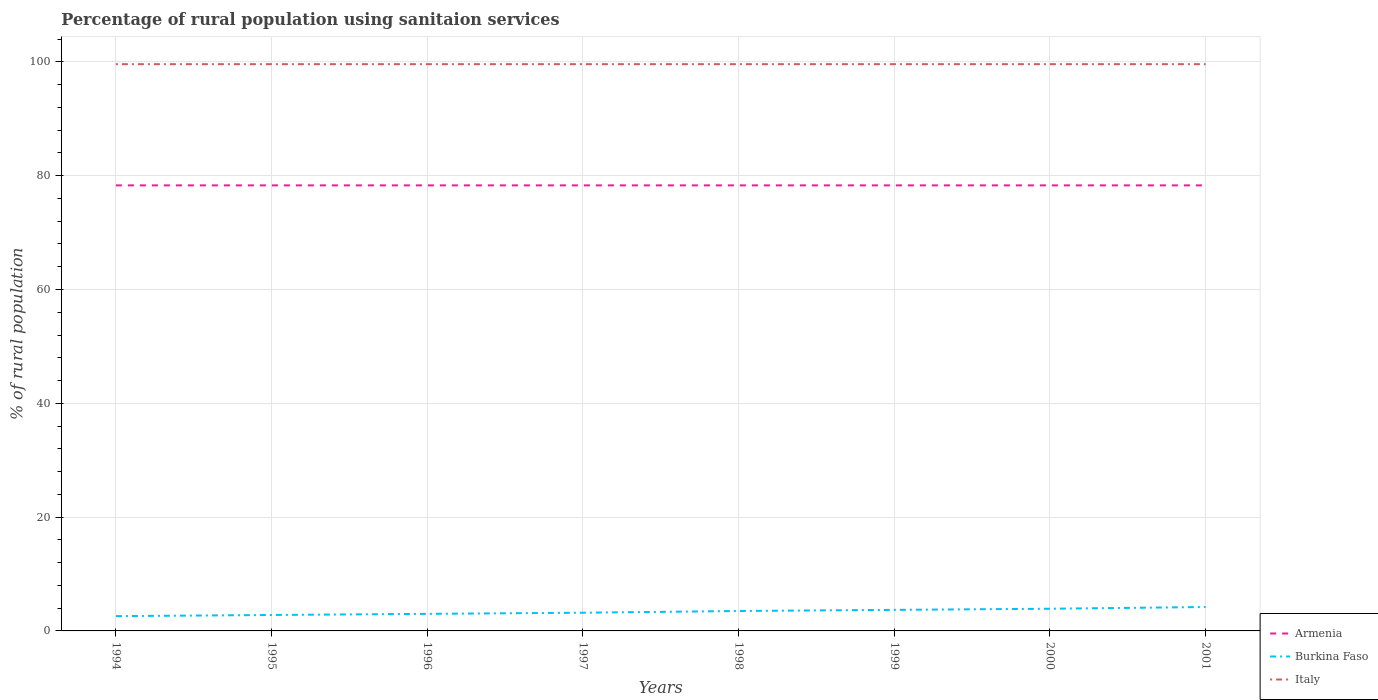Does the line corresponding to Italy intersect with the line corresponding to Armenia?
Offer a terse response. No. Is the number of lines equal to the number of legend labels?
Provide a short and direct response. Yes. Across all years, what is the maximum percentage of rural population using sanitaion services in Burkina Faso?
Your answer should be compact. 2.6. In which year was the percentage of rural population using sanitaion services in Armenia maximum?
Ensure brevity in your answer.  1994. What is the difference between the highest and the second highest percentage of rural population using sanitaion services in Armenia?
Keep it short and to the point. 0. How many lines are there?
Ensure brevity in your answer.  3. What is the difference between two consecutive major ticks on the Y-axis?
Make the answer very short. 20. Are the values on the major ticks of Y-axis written in scientific E-notation?
Offer a terse response. No. Does the graph contain grids?
Offer a very short reply. Yes. How are the legend labels stacked?
Your response must be concise. Vertical. What is the title of the graph?
Your answer should be very brief. Percentage of rural population using sanitaion services. What is the label or title of the Y-axis?
Provide a succinct answer. % of rural population. What is the % of rural population in Armenia in 1994?
Provide a succinct answer. 78.3. What is the % of rural population of Burkina Faso in 1994?
Keep it short and to the point. 2.6. What is the % of rural population of Italy in 1994?
Your answer should be very brief. 99.6. What is the % of rural population in Armenia in 1995?
Your answer should be compact. 78.3. What is the % of rural population of Italy in 1995?
Your answer should be very brief. 99.6. What is the % of rural population in Armenia in 1996?
Make the answer very short. 78.3. What is the % of rural population in Burkina Faso in 1996?
Provide a succinct answer. 3. What is the % of rural population in Italy in 1996?
Offer a terse response. 99.6. What is the % of rural population of Armenia in 1997?
Give a very brief answer. 78.3. What is the % of rural population in Italy in 1997?
Ensure brevity in your answer.  99.6. What is the % of rural population of Armenia in 1998?
Ensure brevity in your answer.  78.3. What is the % of rural population of Italy in 1998?
Provide a succinct answer. 99.6. What is the % of rural population of Armenia in 1999?
Your answer should be very brief. 78.3. What is the % of rural population in Burkina Faso in 1999?
Give a very brief answer. 3.7. What is the % of rural population of Italy in 1999?
Ensure brevity in your answer.  99.6. What is the % of rural population of Armenia in 2000?
Ensure brevity in your answer.  78.3. What is the % of rural population in Italy in 2000?
Provide a short and direct response. 99.6. What is the % of rural population in Armenia in 2001?
Make the answer very short. 78.3. What is the % of rural population in Italy in 2001?
Provide a short and direct response. 99.6. Across all years, what is the maximum % of rural population in Armenia?
Your answer should be compact. 78.3. Across all years, what is the maximum % of rural population in Italy?
Provide a succinct answer. 99.6. Across all years, what is the minimum % of rural population of Armenia?
Offer a terse response. 78.3. Across all years, what is the minimum % of rural population of Burkina Faso?
Your response must be concise. 2.6. Across all years, what is the minimum % of rural population in Italy?
Offer a very short reply. 99.6. What is the total % of rural population of Armenia in the graph?
Make the answer very short. 626.4. What is the total % of rural population in Burkina Faso in the graph?
Ensure brevity in your answer.  26.9. What is the total % of rural population of Italy in the graph?
Ensure brevity in your answer.  796.8. What is the difference between the % of rural population in Armenia in 1994 and that in 1996?
Provide a succinct answer. 0. What is the difference between the % of rural population of Italy in 1994 and that in 1996?
Keep it short and to the point. 0. What is the difference between the % of rural population of Armenia in 1994 and that in 1997?
Provide a succinct answer. 0. What is the difference between the % of rural population in Burkina Faso in 1994 and that in 1997?
Your answer should be compact. -0.6. What is the difference between the % of rural population in Burkina Faso in 1994 and that in 1998?
Provide a succinct answer. -0.9. What is the difference between the % of rural population in Italy in 1994 and that in 1998?
Offer a very short reply. 0. What is the difference between the % of rural population in Italy in 1994 and that in 1999?
Provide a succinct answer. 0. What is the difference between the % of rural population of Armenia in 1994 and that in 2000?
Give a very brief answer. 0. What is the difference between the % of rural population of Burkina Faso in 1994 and that in 2000?
Provide a short and direct response. -1.3. What is the difference between the % of rural population in Burkina Faso in 1994 and that in 2001?
Offer a very short reply. -1.6. What is the difference between the % of rural population of Burkina Faso in 1995 and that in 1996?
Offer a very short reply. -0.2. What is the difference between the % of rural population in Italy in 1995 and that in 1996?
Make the answer very short. 0. What is the difference between the % of rural population in Burkina Faso in 1995 and that in 1997?
Keep it short and to the point. -0.4. What is the difference between the % of rural population of Burkina Faso in 1995 and that in 1998?
Your response must be concise. -0.7. What is the difference between the % of rural population in Armenia in 1995 and that in 1999?
Your answer should be compact. 0. What is the difference between the % of rural population of Burkina Faso in 1995 and that in 1999?
Your answer should be compact. -0.9. What is the difference between the % of rural population of Armenia in 1995 and that in 2000?
Ensure brevity in your answer.  0. What is the difference between the % of rural population in Burkina Faso in 1995 and that in 2000?
Your response must be concise. -1.1. What is the difference between the % of rural population in Italy in 1995 and that in 2000?
Ensure brevity in your answer.  0. What is the difference between the % of rural population in Armenia in 1995 and that in 2001?
Your answer should be very brief. 0. What is the difference between the % of rural population in Armenia in 1996 and that in 1997?
Make the answer very short. 0. What is the difference between the % of rural population of Italy in 1996 and that in 1997?
Offer a terse response. 0. What is the difference between the % of rural population of Burkina Faso in 1996 and that in 1998?
Your response must be concise. -0.5. What is the difference between the % of rural population of Italy in 1996 and that in 1998?
Keep it short and to the point. 0. What is the difference between the % of rural population of Italy in 1996 and that in 1999?
Offer a very short reply. 0. What is the difference between the % of rural population of Burkina Faso in 1996 and that in 2000?
Offer a very short reply. -0.9. What is the difference between the % of rural population of Burkina Faso in 1996 and that in 2001?
Offer a terse response. -1.2. What is the difference between the % of rural population in Italy in 1997 and that in 1998?
Your answer should be very brief. 0. What is the difference between the % of rural population in Burkina Faso in 1997 and that in 2000?
Your response must be concise. -0.7. What is the difference between the % of rural population of Italy in 1997 and that in 2000?
Ensure brevity in your answer.  0. What is the difference between the % of rural population in Italy in 1998 and that in 1999?
Your answer should be very brief. 0. What is the difference between the % of rural population of Armenia in 1998 and that in 2000?
Your response must be concise. 0. What is the difference between the % of rural population of Armenia in 1998 and that in 2001?
Your answer should be compact. 0. What is the difference between the % of rural population of Burkina Faso in 1998 and that in 2001?
Offer a very short reply. -0.7. What is the difference between the % of rural population of Burkina Faso in 1999 and that in 2000?
Your answer should be very brief. -0.2. What is the difference between the % of rural population of Italy in 1999 and that in 2000?
Offer a very short reply. 0. What is the difference between the % of rural population of Armenia in 1999 and that in 2001?
Your answer should be very brief. 0. What is the difference between the % of rural population in Burkina Faso in 1999 and that in 2001?
Give a very brief answer. -0.5. What is the difference between the % of rural population in Burkina Faso in 2000 and that in 2001?
Offer a terse response. -0.3. What is the difference between the % of rural population in Italy in 2000 and that in 2001?
Your answer should be compact. 0. What is the difference between the % of rural population of Armenia in 1994 and the % of rural population of Burkina Faso in 1995?
Provide a succinct answer. 75.5. What is the difference between the % of rural population of Armenia in 1994 and the % of rural population of Italy in 1995?
Give a very brief answer. -21.3. What is the difference between the % of rural population of Burkina Faso in 1994 and the % of rural population of Italy in 1995?
Ensure brevity in your answer.  -97. What is the difference between the % of rural population in Armenia in 1994 and the % of rural population in Burkina Faso in 1996?
Make the answer very short. 75.3. What is the difference between the % of rural population of Armenia in 1994 and the % of rural population of Italy in 1996?
Offer a very short reply. -21.3. What is the difference between the % of rural population of Burkina Faso in 1994 and the % of rural population of Italy in 1996?
Your response must be concise. -97. What is the difference between the % of rural population in Armenia in 1994 and the % of rural population in Burkina Faso in 1997?
Ensure brevity in your answer.  75.1. What is the difference between the % of rural population of Armenia in 1994 and the % of rural population of Italy in 1997?
Make the answer very short. -21.3. What is the difference between the % of rural population in Burkina Faso in 1994 and the % of rural population in Italy in 1997?
Offer a very short reply. -97. What is the difference between the % of rural population in Armenia in 1994 and the % of rural population in Burkina Faso in 1998?
Give a very brief answer. 74.8. What is the difference between the % of rural population of Armenia in 1994 and the % of rural population of Italy in 1998?
Provide a succinct answer. -21.3. What is the difference between the % of rural population of Burkina Faso in 1994 and the % of rural population of Italy in 1998?
Ensure brevity in your answer.  -97. What is the difference between the % of rural population in Armenia in 1994 and the % of rural population in Burkina Faso in 1999?
Give a very brief answer. 74.6. What is the difference between the % of rural population of Armenia in 1994 and the % of rural population of Italy in 1999?
Provide a succinct answer. -21.3. What is the difference between the % of rural population in Burkina Faso in 1994 and the % of rural population in Italy in 1999?
Make the answer very short. -97. What is the difference between the % of rural population of Armenia in 1994 and the % of rural population of Burkina Faso in 2000?
Your response must be concise. 74.4. What is the difference between the % of rural population of Armenia in 1994 and the % of rural population of Italy in 2000?
Give a very brief answer. -21.3. What is the difference between the % of rural population of Burkina Faso in 1994 and the % of rural population of Italy in 2000?
Offer a very short reply. -97. What is the difference between the % of rural population in Armenia in 1994 and the % of rural population in Burkina Faso in 2001?
Your answer should be very brief. 74.1. What is the difference between the % of rural population in Armenia in 1994 and the % of rural population in Italy in 2001?
Your answer should be compact. -21.3. What is the difference between the % of rural population of Burkina Faso in 1994 and the % of rural population of Italy in 2001?
Your answer should be compact. -97. What is the difference between the % of rural population in Armenia in 1995 and the % of rural population in Burkina Faso in 1996?
Make the answer very short. 75.3. What is the difference between the % of rural population of Armenia in 1995 and the % of rural population of Italy in 1996?
Your response must be concise. -21.3. What is the difference between the % of rural population of Burkina Faso in 1995 and the % of rural population of Italy in 1996?
Keep it short and to the point. -96.8. What is the difference between the % of rural population in Armenia in 1995 and the % of rural population in Burkina Faso in 1997?
Your answer should be compact. 75.1. What is the difference between the % of rural population in Armenia in 1995 and the % of rural population in Italy in 1997?
Offer a terse response. -21.3. What is the difference between the % of rural population in Burkina Faso in 1995 and the % of rural population in Italy in 1997?
Make the answer very short. -96.8. What is the difference between the % of rural population in Armenia in 1995 and the % of rural population in Burkina Faso in 1998?
Your answer should be compact. 74.8. What is the difference between the % of rural population of Armenia in 1995 and the % of rural population of Italy in 1998?
Your answer should be very brief. -21.3. What is the difference between the % of rural population of Burkina Faso in 1995 and the % of rural population of Italy in 1998?
Provide a succinct answer. -96.8. What is the difference between the % of rural population in Armenia in 1995 and the % of rural population in Burkina Faso in 1999?
Your answer should be very brief. 74.6. What is the difference between the % of rural population in Armenia in 1995 and the % of rural population in Italy in 1999?
Provide a succinct answer. -21.3. What is the difference between the % of rural population of Burkina Faso in 1995 and the % of rural population of Italy in 1999?
Give a very brief answer. -96.8. What is the difference between the % of rural population of Armenia in 1995 and the % of rural population of Burkina Faso in 2000?
Keep it short and to the point. 74.4. What is the difference between the % of rural population of Armenia in 1995 and the % of rural population of Italy in 2000?
Provide a succinct answer. -21.3. What is the difference between the % of rural population of Burkina Faso in 1995 and the % of rural population of Italy in 2000?
Offer a very short reply. -96.8. What is the difference between the % of rural population in Armenia in 1995 and the % of rural population in Burkina Faso in 2001?
Your answer should be compact. 74.1. What is the difference between the % of rural population in Armenia in 1995 and the % of rural population in Italy in 2001?
Keep it short and to the point. -21.3. What is the difference between the % of rural population in Burkina Faso in 1995 and the % of rural population in Italy in 2001?
Offer a terse response. -96.8. What is the difference between the % of rural population in Armenia in 1996 and the % of rural population in Burkina Faso in 1997?
Your answer should be very brief. 75.1. What is the difference between the % of rural population of Armenia in 1996 and the % of rural population of Italy in 1997?
Provide a short and direct response. -21.3. What is the difference between the % of rural population of Burkina Faso in 1996 and the % of rural population of Italy in 1997?
Your response must be concise. -96.6. What is the difference between the % of rural population of Armenia in 1996 and the % of rural population of Burkina Faso in 1998?
Offer a very short reply. 74.8. What is the difference between the % of rural population of Armenia in 1996 and the % of rural population of Italy in 1998?
Offer a very short reply. -21.3. What is the difference between the % of rural population of Burkina Faso in 1996 and the % of rural population of Italy in 1998?
Offer a terse response. -96.6. What is the difference between the % of rural population of Armenia in 1996 and the % of rural population of Burkina Faso in 1999?
Keep it short and to the point. 74.6. What is the difference between the % of rural population in Armenia in 1996 and the % of rural population in Italy in 1999?
Ensure brevity in your answer.  -21.3. What is the difference between the % of rural population of Burkina Faso in 1996 and the % of rural population of Italy in 1999?
Give a very brief answer. -96.6. What is the difference between the % of rural population of Armenia in 1996 and the % of rural population of Burkina Faso in 2000?
Your answer should be very brief. 74.4. What is the difference between the % of rural population in Armenia in 1996 and the % of rural population in Italy in 2000?
Offer a terse response. -21.3. What is the difference between the % of rural population in Burkina Faso in 1996 and the % of rural population in Italy in 2000?
Ensure brevity in your answer.  -96.6. What is the difference between the % of rural population in Armenia in 1996 and the % of rural population in Burkina Faso in 2001?
Offer a terse response. 74.1. What is the difference between the % of rural population of Armenia in 1996 and the % of rural population of Italy in 2001?
Provide a succinct answer. -21.3. What is the difference between the % of rural population of Burkina Faso in 1996 and the % of rural population of Italy in 2001?
Provide a succinct answer. -96.6. What is the difference between the % of rural population in Armenia in 1997 and the % of rural population in Burkina Faso in 1998?
Offer a terse response. 74.8. What is the difference between the % of rural population in Armenia in 1997 and the % of rural population in Italy in 1998?
Offer a very short reply. -21.3. What is the difference between the % of rural population in Burkina Faso in 1997 and the % of rural population in Italy in 1998?
Make the answer very short. -96.4. What is the difference between the % of rural population in Armenia in 1997 and the % of rural population in Burkina Faso in 1999?
Your answer should be very brief. 74.6. What is the difference between the % of rural population of Armenia in 1997 and the % of rural population of Italy in 1999?
Your answer should be very brief. -21.3. What is the difference between the % of rural population in Burkina Faso in 1997 and the % of rural population in Italy in 1999?
Your answer should be very brief. -96.4. What is the difference between the % of rural population of Armenia in 1997 and the % of rural population of Burkina Faso in 2000?
Give a very brief answer. 74.4. What is the difference between the % of rural population of Armenia in 1997 and the % of rural population of Italy in 2000?
Provide a succinct answer. -21.3. What is the difference between the % of rural population of Burkina Faso in 1997 and the % of rural population of Italy in 2000?
Give a very brief answer. -96.4. What is the difference between the % of rural population of Armenia in 1997 and the % of rural population of Burkina Faso in 2001?
Offer a terse response. 74.1. What is the difference between the % of rural population of Armenia in 1997 and the % of rural population of Italy in 2001?
Your response must be concise. -21.3. What is the difference between the % of rural population of Burkina Faso in 1997 and the % of rural population of Italy in 2001?
Your answer should be very brief. -96.4. What is the difference between the % of rural population in Armenia in 1998 and the % of rural population in Burkina Faso in 1999?
Provide a short and direct response. 74.6. What is the difference between the % of rural population of Armenia in 1998 and the % of rural population of Italy in 1999?
Offer a terse response. -21.3. What is the difference between the % of rural population of Burkina Faso in 1998 and the % of rural population of Italy in 1999?
Your response must be concise. -96.1. What is the difference between the % of rural population of Armenia in 1998 and the % of rural population of Burkina Faso in 2000?
Ensure brevity in your answer.  74.4. What is the difference between the % of rural population of Armenia in 1998 and the % of rural population of Italy in 2000?
Your answer should be compact. -21.3. What is the difference between the % of rural population of Burkina Faso in 1998 and the % of rural population of Italy in 2000?
Your answer should be compact. -96.1. What is the difference between the % of rural population of Armenia in 1998 and the % of rural population of Burkina Faso in 2001?
Make the answer very short. 74.1. What is the difference between the % of rural population of Armenia in 1998 and the % of rural population of Italy in 2001?
Your response must be concise. -21.3. What is the difference between the % of rural population in Burkina Faso in 1998 and the % of rural population in Italy in 2001?
Give a very brief answer. -96.1. What is the difference between the % of rural population of Armenia in 1999 and the % of rural population of Burkina Faso in 2000?
Offer a terse response. 74.4. What is the difference between the % of rural population of Armenia in 1999 and the % of rural population of Italy in 2000?
Make the answer very short. -21.3. What is the difference between the % of rural population in Burkina Faso in 1999 and the % of rural population in Italy in 2000?
Provide a short and direct response. -95.9. What is the difference between the % of rural population in Armenia in 1999 and the % of rural population in Burkina Faso in 2001?
Ensure brevity in your answer.  74.1. What is the difference between the % of rural population in Armenia in 1999 and the % of rural population in Italy in 2001?
Your response must be concise. -21.3. What is the difference between the % of rural population in Burkina Faso in 1999 and the % of rural population in Italy in 2001?
Your answer should be very brief. -95.9. What is the difference between the % of rural population of Armenia in 2000 and the % of rural population of Burkina Faso in 2001?
Provide a succinct answer. 74.1. What is the difference between the % of rural population in Armenia in 2000 and the % of rural population in Italy in 2001?
Ensure brevity in your answer.  -21.3. What is the difference between the % of rural population in Burkina Faso in 2000 and the % of rural population in Italy in 2001?
Offer a very short reply. -95.7. What is the average % of rural population of Armenia per year?
Provide a short and direct response. 78.3. What is the average % of rural population of Burkina Faso per year?
Give a very brief answer. 3.36. What is the average % of rural population of Italy per year?
Give a very brief answer. 99.6. In the year 1994, what is the difference between the % of rural population of Armenia and % of rural population of Burkina Faso?
Make the answer very short. 75.7. In the year 1994, what is the difference between the % of rural population in Armenia and % of rural population in Italy?
Keep it short and to the point. -21.3. In the year 1994, what is the difference between the % of rural population in Burkina Faso and % of rural population in Italy?
Provide a short and direct response. -97. In the year 1995, what is the difference between the % of rural population in Armenia and % of rural population in Burkina Faso?
Your answer should be very brief. 75.5. In the year 1995, what is the difference between the % of rural population in Armenia and % of rural population in Italy?
Offer a terse response. -21.3. In the year 1995, what is the difference between the % of rural population of Burkina Faso and % of rural population of Italy?
Your answer should be very brief. -96.8. In the year 1996, what is the difference between the % of rural population of Armenia and % of rural population of Burkina Faso?
Keep it short and to the point. 75.3. In the year 1996, what is the difference between the % of rural population of Armenia and % of rural population of Italy?
Give a very brief answer. -21.3. In the year 1996, what is the difference between the % of rural population of Burkina Faso and % of rural population of Italy?
Give a very brief answer. -96.6. In the year 1997, what is the difference between the % of rural population in Armenia and % of rural population in Burkina Faso?
Your response must be concise. 75.1. In the year 1997, what is the difference between the % of rural population of Armenia and % of rural population of Italy?
Ensure brevity in your answer.  -21.3. In the year 1997, what is the difference between the % of rural population in Burkina Faso and % of rural population in Italy?
Give a very brief answer. -96.4. In the year 1998, what is the difference between the % of rural population in Armenia and % of rural population in Burkina Faso?
Ensure brevity in your answer.  74.8. In the year 1998, what is the difference between the % of rural population in Armenia and % of rural population in Italy?
Offer a terse response. -21.3. In the year 1998, what is the difference between the % of rural population of Burkina Faso and % of rural population of Italy?
Make the answer very short. -96.1. In the year 1999, what is the difference between the % of rural population in Armenia and % of rural population in Burkina Faso?
Your response must be concise. 74.6. In the year 1999, what is the difference between the % of rural population of Armenia and % of rural population of Italy?
Your response must be concise. -21.3. In the year 1999, what is the difference between the % of rural population in Burkina Faso and % of rural population in Italy?
Make the answer very short. -95.9. In the year 2000, what is the difference between the % of rural population in Armenia and % of rural population in Burkina Faso?
Offer a terse response. 74.4. In the year 2000, what is the difference between the % of rural population in Armenia and % of rural population in Italy?
Give a very brief answer. -21.3. In the year 2000, what is the difference between the % of rural population in Burkina Faso and % of rural population in Italy?
Your answer should be compact. -95.7. In the year 2001, what is the difference between the % of rural population of Armenia and % of rural population of Burkina Faso?
Give a very brief answer. 74.1. In the year 2001, what is the difference between the % of rural population in Armenia and % of rural population in Italy?
Give a very brief answer. -21.3. In the year 2001, what is the difference between the % of rural population of Burkina Faso and % of rural population of Italy?
Offer a very short reply. -95.4. What is the ratio of the % of rural population of Armenia in 1994 to that in 1996?
Provide a short and direct response. 1. What is the ratio of the % of rural population in Burkina Faso in 1994 to that in 1996?
Offer a terse response. 0.87. What is the ratio of the % of rural population of Burkina Faso in 1994 to that in 1997?
Offer a very short reply. 0.81. What is the ratio of the % of rural population of Italy in 1994 to that in 1997?
Ensure brevity in your answer.  1. What is the ratio of the % of rural population in Armenia in 1994 to that in 1998?
Keep it short and to the point. 1. What is the ratio of the % of rural population in Burkina Faso in 1994 to that in 1998?
Offer a terse response. 0.74. What is the ratio of the % of rural population in Italy in 1994 to that in 1998?
Give a very brief answer. 1. What is the ratio of the % of rural population of Burkina Faso in 1994 to that in 1999?
Offer a terse response. 0.7. What is the ratio of the % of rural population of Burkina Faso in 1994 to that in 2000?
Provide a succinct answer. 0.67. What is the ratio of the % of rural population of Italy in 1994 to that in 2000?
Your answer should be very brief. 1. What is the ratio of the % of rural population in Armenia in 1994 to that in 2001?
Keep it short and to the point. 1. What is the ratio of the % of rural population in Burkina Faso in 1994 to that in 2001?
Offer a terse response. 0.62. What is the ratio of the % of rural population in Italy in 1994 to that in 2001?
Provide a succinct answer. 1. What is the ratio of the % of rural population in Armenia in 1995 to that in 1996?
Your response must be concise. 1. What is the ratio of the % of rural population in Burkina Faso in 1995 to that in 1996?
Your answer should be compact. 0.93. What is the ratio of the % of rural population of Burkina Faso in 1995 to that in 1997?
Ensure brevity in your answer.  0.88. What is the ratio of the % of rural population of Burkina Faso in 1995 to that in 1998?
Provide a succinct answer. 0.8. What is the ratio of the % of rural population of Italy in 1995 to that in 1998?
Give a very brief answer. 1. What is the ratio of the % of rural population of Burkina Faso in 1995 to that in 1999?
Ensure brevity in your answer.  0.76. What is the ratio of the % of rural population in Italy in 1995 to that in 1999?
Provide a short and direct response. 1. What is the ratio of the % of rural population of Burkina Faso in 1995 to that in 2000?
Give a very brief answer. 0.72. What is the ratio of the % of rural population in Italy in 1995 to that in 2000?
Provide a succinct answer. 1. What is the ratio of the % of rural population in Burkina Faso in 1996 to that in 1997?
Your answer should be compact. 0.94. What is the ratio of the % of rural population in Italy in 1996 to that in 1997?
Your response must be concise. 1. What is the ratio of the % of rural population of Burkina Faso in 1996 to that in 1999?
Your response must be concise. 0.81. What is the ratio of the % of rural population of Italy in 1996 to that in 1999?
Offer a terse response. 1. What is the ratio of the % of rural population of Armenia in 1996 to that in 2000?
Provide a succinct answer. 1. What is the ratio of the % of rural population in Burkina Faso in 1996 to that in 2000?
Offer a terse response. 0.77. What is the ratio of the % of rural population of Italy in 1996 to that in 2000?
Provide a short and direct response. 1. What is the ratio of the % of rural population in Burkina Faso in 1996 to that in 2001?
Provide a short and direct response. 0.71. What is the ratio of the % of rural population of Italy in 1996 to that in 2001?
Your response must be concise. 1. What is the ratio of the % of rural population in Armenia in 1997 to that in 1998?
Your answer should be compact. 1. What is the ratio of the % of rural population of Burkina Faso in 1997 to that in 1998?
Ensure brevity in your answer.  0.91. What is the ratio of the % of rural population in Italy in 1997 to that in 1998?
Make the answer very short. 1. What is the ratio of the % of rural population in Burkina Faso in 1997 to that in 1999?
Ensure brevity in your answer.  0.86. What is the ratio of the % of rural population of Burkina Faso in 1997 to that in 2000?
Ensure brevity in your answer.  0.82. What is the ratio of the % of rural population of Italy in 1997 to that in 2000?
Provide a short and direct response. 1. What is the ratio of the % of rural population of Burkina Faso in 1997 to that in 2001?
Offer a very short reply. 0.76. What is the ratio of the % of rural population of Italy in 1997 to that in 2001?
Give a very brief answer. 1. What is the ratio of the % of rural population in Armenia in 1998 to that in 1999?
Offer a very short reply. 1. What is the ratio of the % of rural population of Burkina Faso in 1998 to that in 1999?
Provide a succinct answer. 0.95. What is the ratio of the % of rural population in Burkina Faso in 1998 to that in 2000?
Offer a terse response. 0.9. What is the ratio of the % of rural population of Burkina Faso in 1998 to that in 2001?
Offer a very short reply. 0.83. What is the ratio of the % of rural population of Armenia in 1999 to that in 2000?
Offer a terse response. 1. What is the ratio of the % of rural population in Burkina Faso in 1999 to that in 2000?
Your response must be concise. 0.95. What is the ratio of the % of rural population of Italy in 1999 to that in 2000?
Ensure brevity in your answer.  1. What is the ratio of the % of rural population of Burkina Faso in 1999 to that in 2001?
Your response must be concise. 0.88. What is the ratio of the % of rural population of Italy in 2000 to that in 2001?
Offer a terse response. 1. What is the difference between the highest and the second highest % of rural population of Burkina Faso?
Your response must be concise. 0.3. What is the difference between the highest and the lowest % of rural population in Armenia?
Ensure brevity in your answer.  0. What is the difference between the highest and the lowest % of rural population of Burkina Faso?
Your answer should be very brief. 1.6. What is the difference between the highest and the lowest % of rural population of Italy?
Provide a succinct answer. 0. 